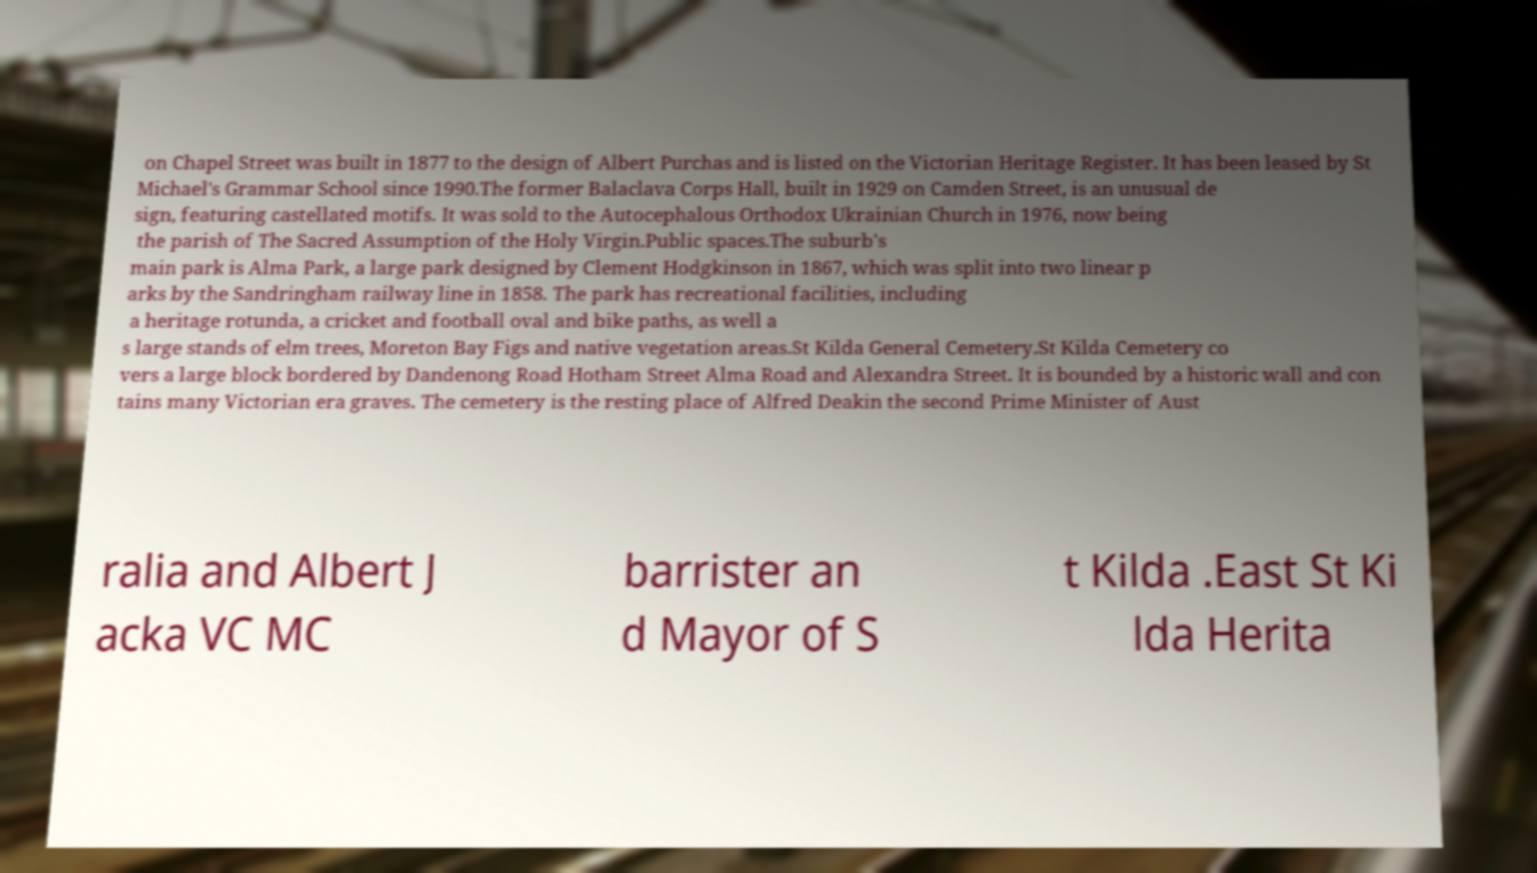I need the written content from this picture converted into text. Can you do that? on Chapel Street was built in 1877 to the design of Albert Purchas and is listed on the Victorian Heritage Register. It has been leased by St Michael's Grammar School since 1990.The former Balaclava Corps Hall, built in 1929 on Camden Street, is an unusual de sign, featuring castellated motifs. It was sold to the Autocephalous Orthodox Ukrainian Church in 1976, now being the parish of The Sacred Assumption of the Holy Virgin.Public spaces.The suburb's main park is Alma Park, a large park designed by Clement Hodgkinson in 1867, which was split into two linear p arks by the Sandringham railway line in 1858. The park has recreational facilities, including a heritage rotunda, a cricket and football oval and bike paths, as well a s large stands of elm trees, Moreton Bay Figs and native vegetation areas.St Kilda General Cemetery.St Kilda Cemetery co vers a large block bordered by Dandenong Road Hotham Street Alma Road and Alexandra Street. It is bounded by a historic wall and con tains many Victorian era graves. The cemetery is the resting place of Alfred Deakin the second Prime Minister of Aust ralia and Albert J acka VC MC barrister an d Mayor of S t Kilda .East St Ki lda Herita 